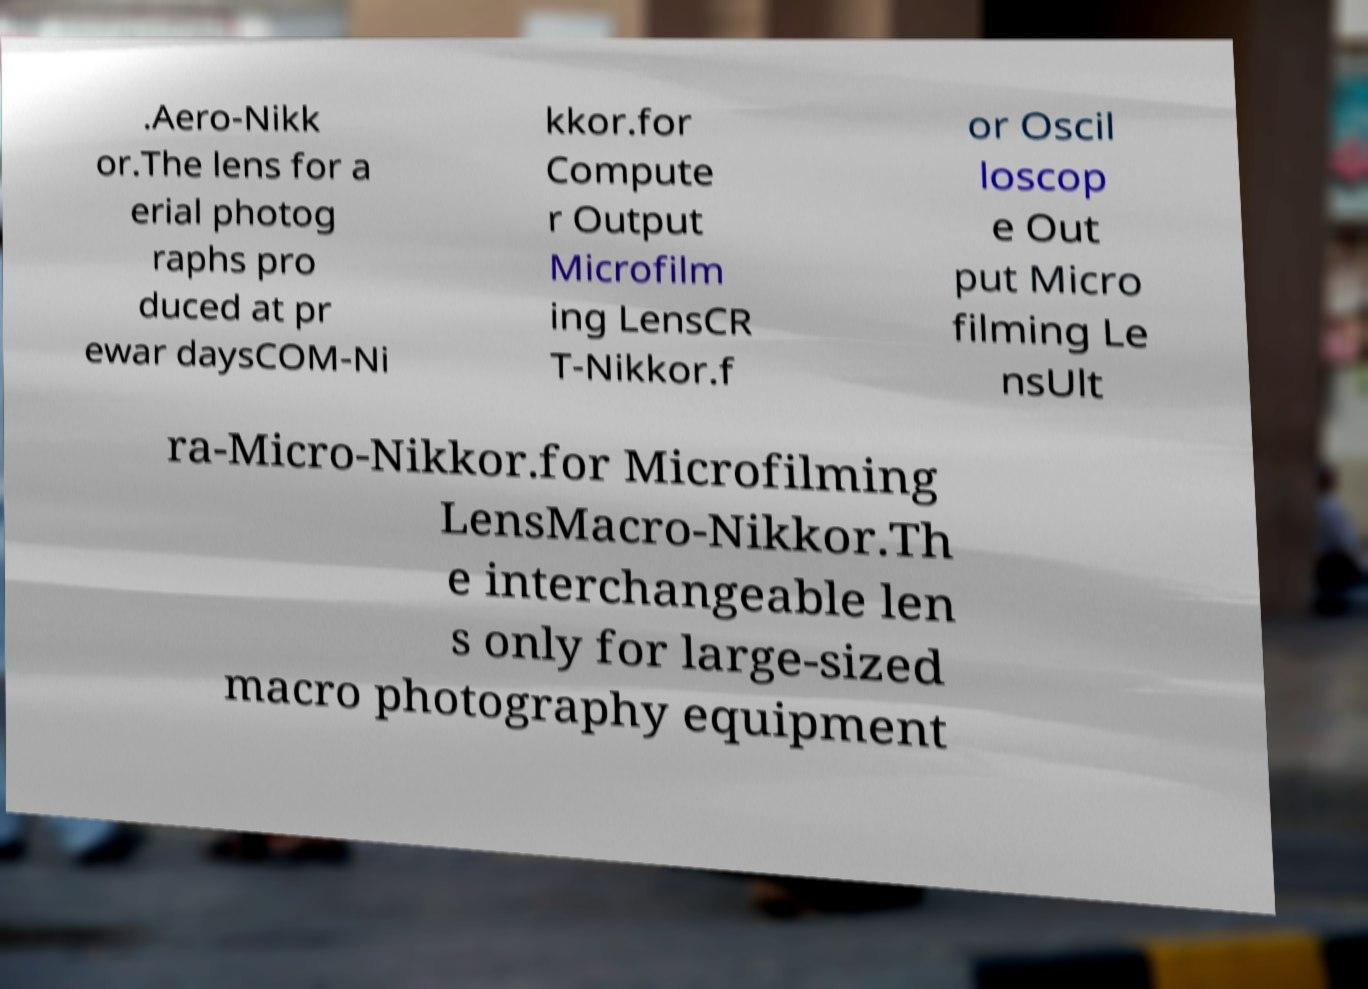Could you extract and type out the text from this image? .Aero-Nikk or.The lens for a erial photog raphs pro duced at pr ewar daysCOM-Ni kkor.for Compute r Output Microfilm ing LensCR T-Nikkor.f or Oscil loscop e Out put Micro filming Le nsUlt ra-Micro-Nikkor.for Microfilming LensMacro-Nikkor.Th e interchangeable len s only for large-sized macro photography equipment 